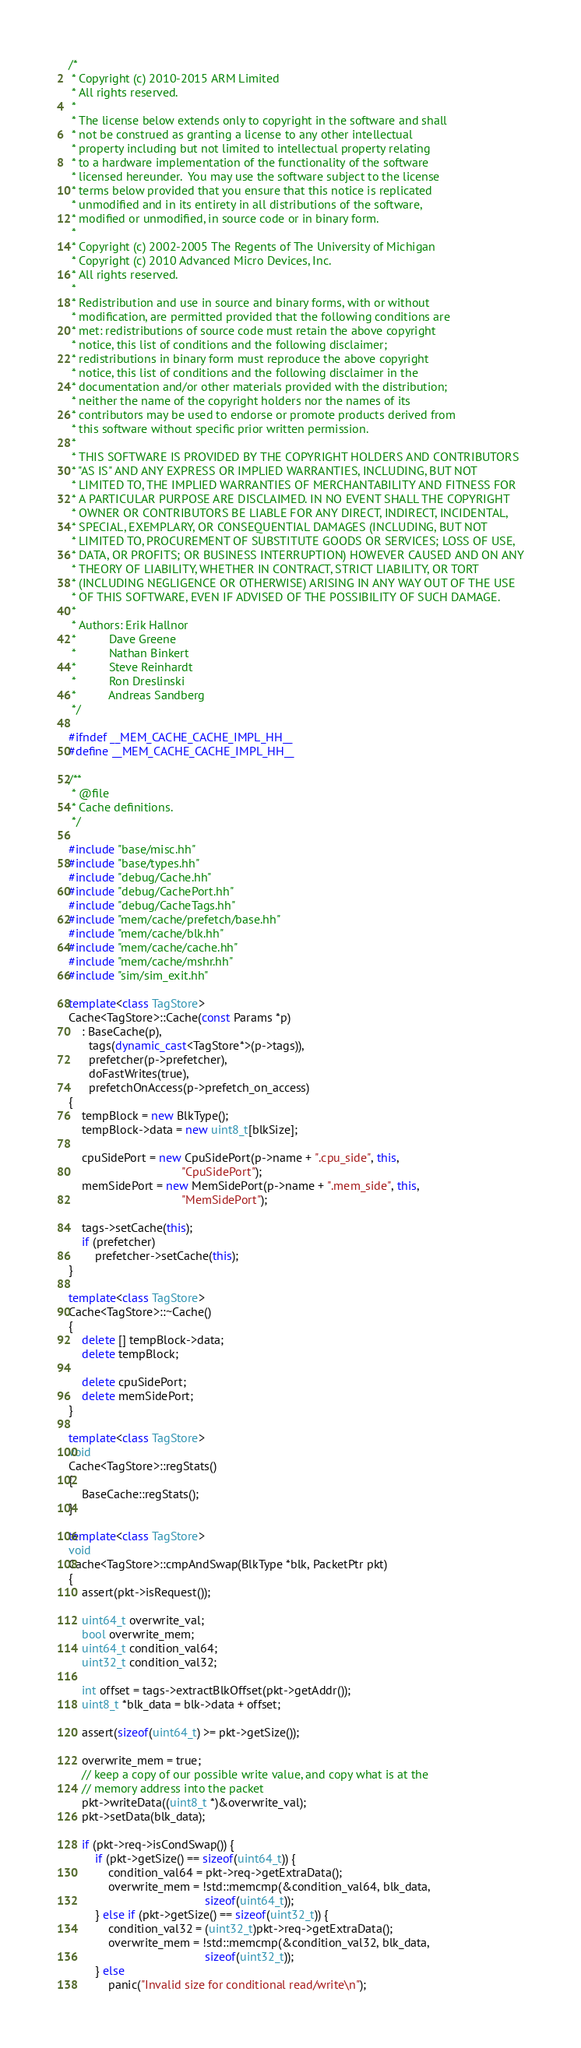<code> <loc_0><loc_0><loc_500><loc_500><_C++_>/*
 * Copyright (c) 2010-2015 ARM Limited
 * All rights reserved.
 *
 * The license below extends only to copyright in the software and shall
 * not be construed as granting a license to any other intellectual
 * property including but not limited to intellectual property relating
 * to a hardware implementation of the functionality of the software
 * licensed hereunder.  You may use the software subject to the license
 * terms below provided that you ensure that this notice is replicated
 * unmodified and in its entirety in all distributions of the software,
 * modified or unmodified, in source code or in binary form.
 *
 * Copyright (c) 2002-2005 The Regents of The University of Michigan
 * Copyright (c) 2010 Advanced Micro Devices, Inc.
 * All rights reserved.
 *
 * Redistribution and use in source and binary forms, with or without
 * modification, are permitted provided that the following conditions are
 * met: redistributions of source code must retain the above copyright
 * notice, this list of conditions and the following disclaimer;
 * redistributions in binary form must reproduce the above copyright
 * notice, this list of conditions and the following disclaimer in the
 * documentation and/or other materials provided with the distribution;
 * neither the name of the copyright holders nor the names of its
 * contributors may be used to endorse or promote products derived from
 * this software without specific prior written permission.
 *
 * THIS SOFTWARE IS PROVIDED BY THE COPYRIGHT HOLDERS AND CONTRIBUTORS
 * "AS IS" AND ANY EXPRESS OR IMPLIED WARRANTIES, INCLUDING, BUT NOT
 * LIMITED TO, THE IMPLIED WARRANTIES OF MERCHANTABILITY AND FITNESS FOR
 * A PARTICULAR PURPOSE ARE DISCLAIMED. IN NO EVENT SHALL THE COPYRIGHT
 * OWNER OR CONTRIBUTORS BE LIABLE FOR ANY DIRECT, INDIRECT, INCIDENTAL,
 * SPECIAL, EXEMPLARY, OR CONSEQUENTIAL DAMAGES (INCLUDING, BUT NOT
 * LIMITED TO, PROCUREMENT OF SUBSTITUTE GOODS OR SERVICES; LOSS OF USE,
 * DATA, OR PROFITS; OR BUSINESS INTERRUPTION) HOWEVER CAUSED AND ON ANY
 * THEORY OF LIABILITY, WHETHER IN CONTRACT, STRICT LIABILITY, OR TORT
 * (INCLUDING NEGLIGENCE OR OTHERWISE) ARISING IN ANY WAY OUT OF THE USE
 * OF THIS SOFTWARE, EVEN IF ADVISED OF THE POSSIBILITY OF SUCH DAMAGE.
 *
 * Authors: Erik Hallnor
 *          Dave Greene
 *          Nathan Binkert
 *          Steve Reinhardt
 *          Ron Dreslinski
 *          Andreas Sandberg
 */

#ifndef __MEM_CACHE_CACHE_IMPL_HH__
#define __MEM_CACHE_CACHE_IMPL_HH__

/**
 * @file
 * Cache definitions.
 */

#include "base/misc.hh"
#include "base/types.hh"
#include "debug/Cache.hh"
#include "debug/CachePort.hh"
#include "debug/CacheTags.hh"
#include "mem/cache/prefetch/base.hh"
#include "mem/cache/blk.hh"
#include "mem/cache/cache.hh"
#include "mem/cache/mshr.hh"
#include "sim/sim_exit.hh"

template<class TagStore>
Cache<TagStore>::Cache(const Params *p)
    : BaseCache(p),
      tags(dynamic_cast<TagStore*>(p->tags)),
      prefetcher(p->prefetcher),
      doFastWrites(true),
      prefetchOnAccess(p->prefetch_on_access)
{
    tempBlock = new BlkType();
    tempBlock->data = new uint8_t[blkSize];

    cpuSidePort = new CpuSidePort(p->name + ".cpu_side", this,
                                  "CpuSidePort");
    memSidePort = new MemSidePort(p->name + ".mem_side", this,
                                  "MemSidePort");

    tags->setCache(this);
    if (prefetcher)
        prefetcher->setCache(this);
}

template<class TagStore>
Cache<TagStore>::~Cache()
{
    delete [] tempBlock->data;
    delete tempBlock;

    delete cpuSidePort;
    delete memSidePort;
}

template<class TagStore>
void
Cache<TagStore>::regStats()
{
    BaseCache::regStats();
}

template<class TagStore>
void
Cache<TagStore>::cmpAndSwap(BlkType *blk, PacketPtr pkt)
{
    assert(pkt->isRequest());

    uint64_t overwrite_val;
    bool overwrite_mem;
    uint64_t condition_val64;
    uint32_t condition_val32;

    int offset = tags->extractBlkOffset(pkt->getAddr());
    uint8_t *blk_data = blk->data + offset;

    assert(sizeof(uint64_t) >= pkt->getSize());

    overwrite_mem = true;
    // keep a copy of our possible write value, and copy what is at the
    // memory address into the packet
    pkt->writeData((uint8_t *)&overwrite_val);
    pkt->setData(blk_data);

    if (pkt->req->isCondSwap()) {
        if (pkt->getSize() == sizeof(uint64_t)) {
            condition_val64 = pkt->req->getExtraData();
            overwrite_mem = !std::memcmp(&condition_val64, blk_data,
                                         sizeof(uint64_t));
        } else if (pkt->getSize() == sizeof(uint32_t)) {
            condition_val32 = (uint32_t)pkt->req->getExtraData();
            overwrite_mem = !std::memcmp(&condition_val32, blk_data,
                                         sizeof(uint32_t));
        } else
            panic("Invalid size for conditional read/write\n");</code> 